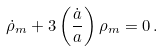<formula> <loc_0><loc_0><loc_500><loc_500>\dot { \rho } _ { m } + 3 \left ( \frac { \dot { a } } { a } \right ) \rho _ { m } = 0 \, .</formula> 